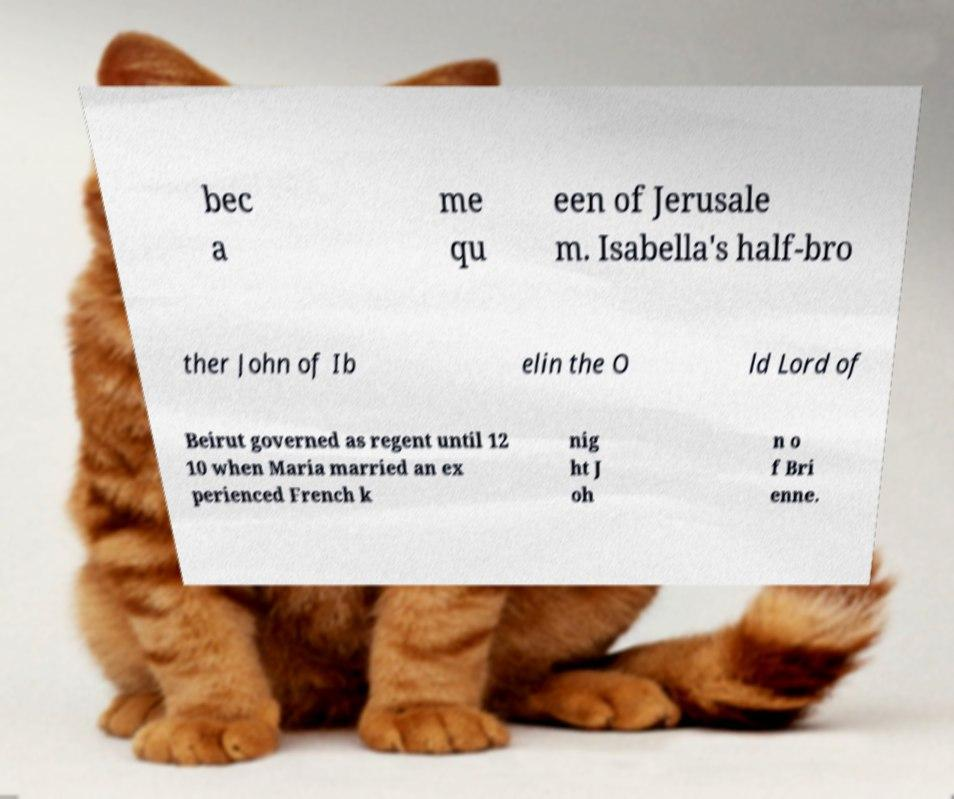For documentation purposes, I need the text within this image transcribed. Could you provide that? bec a me qu een of Jerusale m. Isabella's half-bro ther John of Ib elin the O ld Lord of Beirut governed as regent until 12 10 when Maria married an ex perienced French k nig ht J oh n o f Bri enne. 